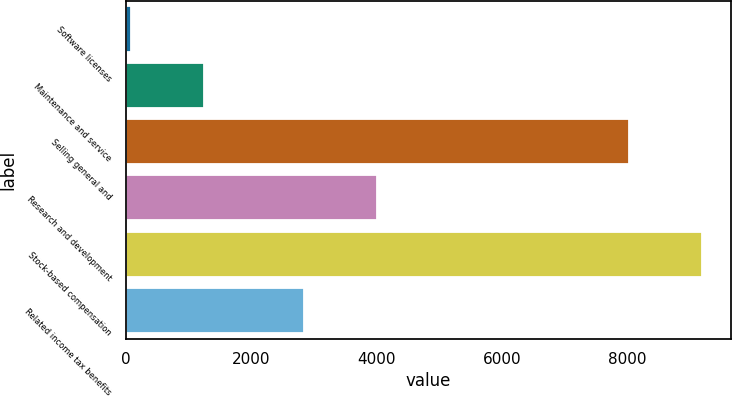Convert chart to OTSL. <chart><loc_0><loc_0><loc_500><loc_500><bar_chart><fcel>Software licenses<fcel>Maintenance and service<fcel>Selling general and<fcel>Research and development<fcel>Stock-based compensation<fcel>Related income tax benefits<nl><fcel>72<fcel>1242.7<fcel>8022<fcel>4003.7<fcel>9192.7<fcel>2833<nl></chart> 